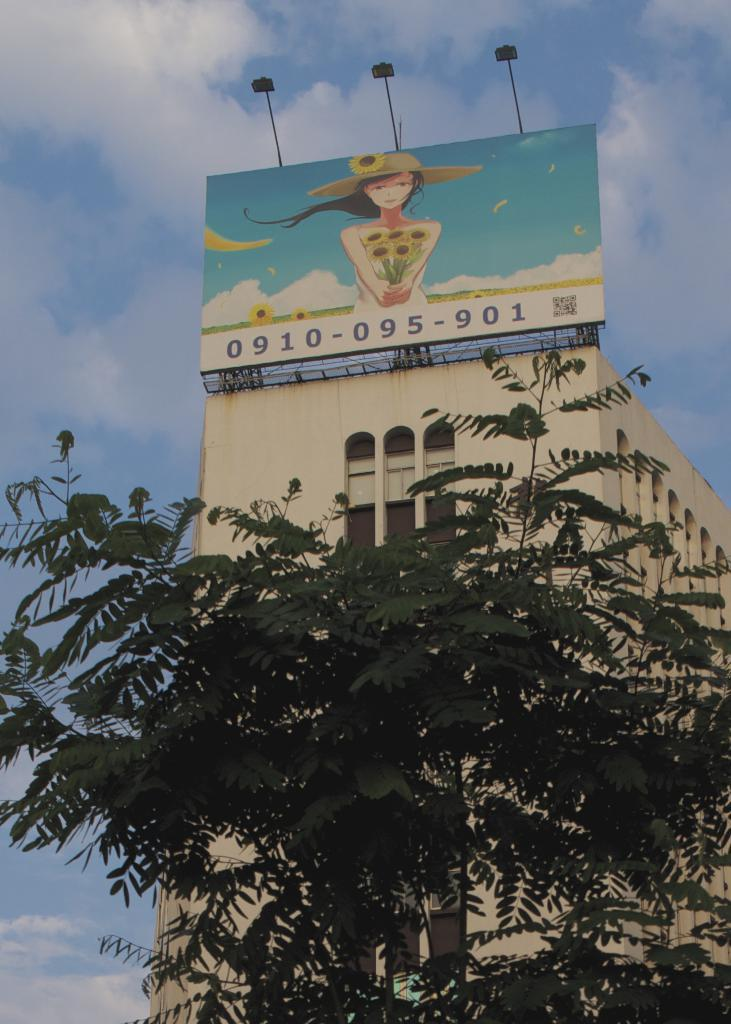What type of vegetation can be seen in the image? There are trees in the image. What color are the trees? The trees are green. What can be seen in the background of the image? There is a building, a board, and lights visible in the background of the image. What is the color of the sky in the image? The sky is blue and white in color. How many eggs are being used in the operation depicted in the image? There is no operation or eggs present in the image. What type of brick is being used to construct the building in the image? There is no visible brick in the image, and the building's construction materials cannot be determined from the image. 